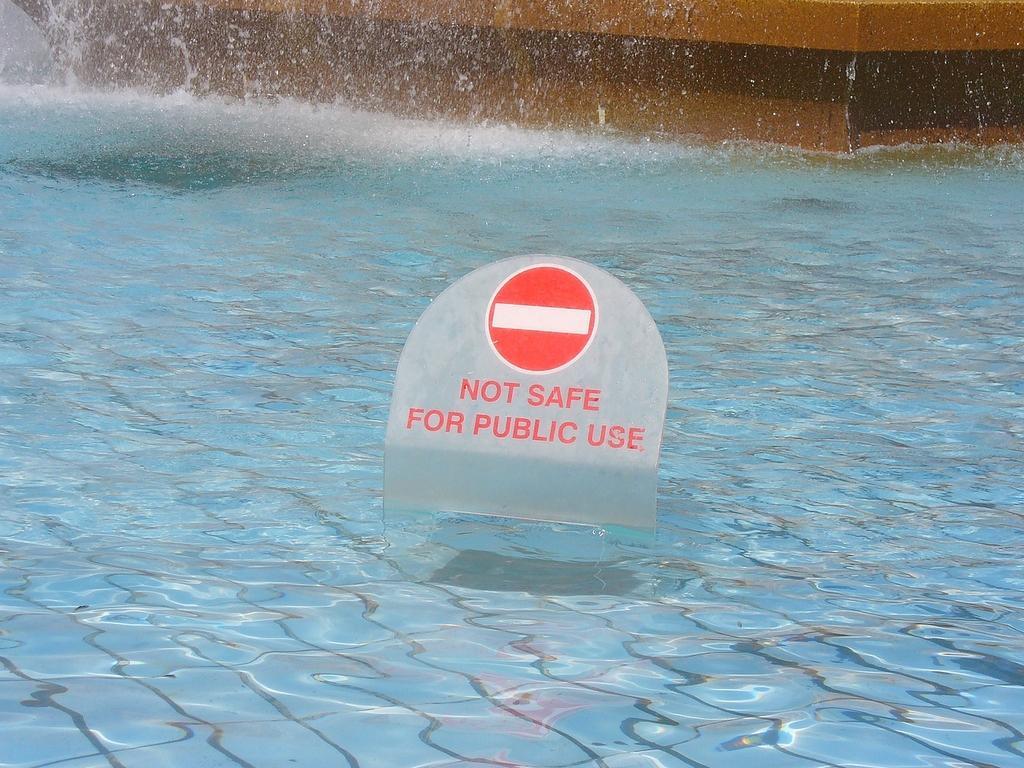In one or two sentences, can you explain what this image depicts? In this image, I can see a signboard in the water. In the background there is a wall. 